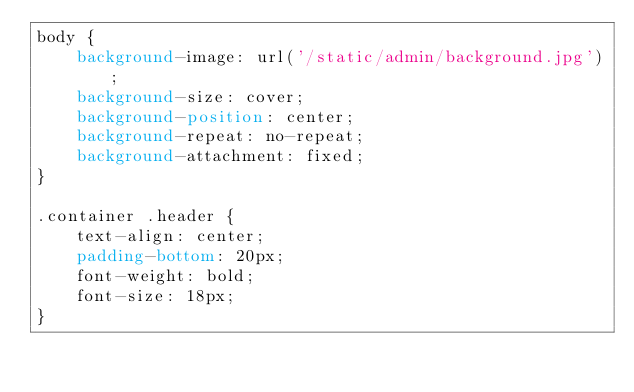Convert code to text. <code><loc_0><loc_0><loc_500><loc_500><_CSS_>body {
    background-image: url('/static/admin/background.jpg');
    background-size: cover;
    background-position: center;
    background-repeat: no-repeat;
    background-attachment: fixed;
}

.container .header {
    text-align: center;
    padding-bottom: 20px;
    font-weight: bold;
    font-size: 18px;
}</code> 